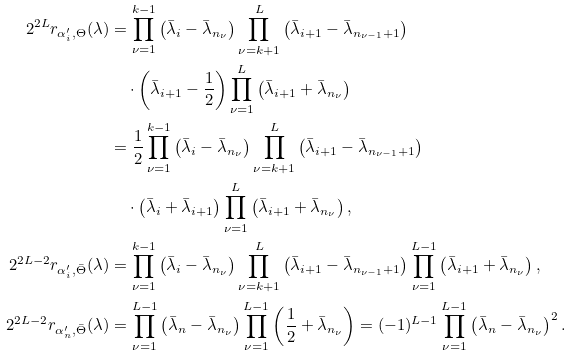Convert formula to latex. <formula><loc_0><loc_0><loc_500><loc_500>2 ^ { 2 L } r _ { \alpha ^ { \prime } _ { i } , \Theta } ( \lambda ) & = \prod _ { \nu = 1 } ^ { k - 1 } \left ( \bar { \lambda } _ { i } - \bar { \lambda } _ { n _ { \nu } } \right ) \prod _ { \nu = k + 1 } ^ { L } \left ( \bar { \lambda } _ { i + 1 } - \bar { \lambda } _ { n _ { \nu - 1 } + 1 } \right ) \\ & \quad \cdot \left ( \bar { \lambda } _ { i + 1 } - \frac { 1 } { 2 } \right ) \prod _ { \nu = 1 } ^ { L } \left ( \bar { \lambda } _ { i + 1 } + \bar { \lambda } _ { n _ { \nu } } \right ) \\ & = \frac { 1 } { 2 } \prod _ { \nu = 1 } ^ { k - 1 } \left ( \bar { \lambda } _ { i } - \bar { \lambda } _ { n _ { \nu } } \right ) \prod _ { \nu = k + 1 } ^ { L } \left ( \bar { \lambda } _ { i + 1 } - \bar { \lambda } _ { n _ { \nu - 1 } + 1 } \right ) \\ & \quad \cdot \left ( \bar { \lambda } _ { i } + \bar { \lambda } _ { i + 1 } \right ) \prod _ { \nu = 1 } ^ { L } \left ( \bar { \lambda } _ { i + 1 } + \bar { \lambda } _ { n _ { \nu } } \right ) , \\ 2 ^ { 2 L - 2 } r _ { \alpha ^ { \prime } _ { i } , \bar { \Theta } } ( \lambda ) & = \prod _ { \nu = 1 } ^ { k - 1 } \left ( \bar { \lambda } _ { i } - \bar { \lambda } _ { n _ { \nu } } \right ) \prod _ { \nu = k + 1 } ^ { L } \left ( \bar { \lambda } _ { i + 1 } - \bar { \lambda } _ { n _ { \nu - 1 } + 1 } \right ) \prod _ { \nu = 1 } ^ { L - 1 } \left ( \bar { \lambda } _ { i + 1 } + \bar { \lambda } _ { n _ { \nu } } \right ) , \\ 2 ^ { 2 L - 2 } r _ { \alpha ^ { \prime } _ { n } , \bar { \Theta } } ( \lambda ) & = \prod _ { \nu = 1 } ^ { L - 1 } \left ( \bar { \lambda } _ { n } - \bar { \lambda } _ { n _ { \nu } } \right ) \prod _ { \nu = 1 } ^ { L - 1 } \left ( \frac { 1 } { 2 } + \bar { \lambda } _ { n _ { \nu } } \right ) = ( - 1 ) ^ { L - 1 } \prod _ { \nu = 1 } ^ { L - 1 } \left ( \bar { \lambda } _ { n } - \bar { \lambda } _ { n _ { \nu } } \right ) ^ { 2 } .</formula> 